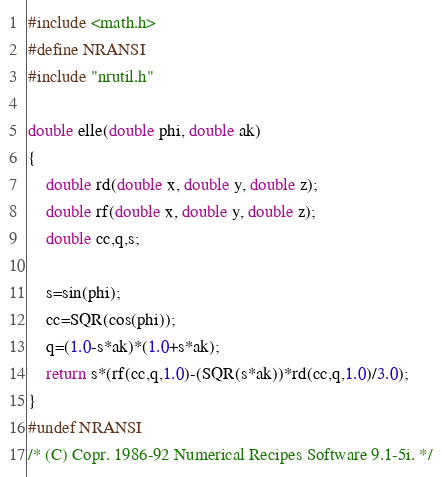<code> <loc_0><loc_0><loc_500><loc_500><_C_>#include <math.h>
#define NRANSI
#include "nrutil.h"

double elle(double phi, double ak)
{
	double rd(double x, double y, double z);
	double rf(double x, double y, double z);
	double cc,q,s;

	s=sin(phi);
	cc=SQR(cos(phi));
	q=(1.0-s*ak)*(1.0+s*ak);
	return s*(rf(cc,q,1.0)-(SQR(s*ak))*rd(cc,q,1.0)/3.0);
}
#undef NRANSI
/* (C) Copr. 1986-92 Numerical Recipes Software 9.1-5i. */
</code> 